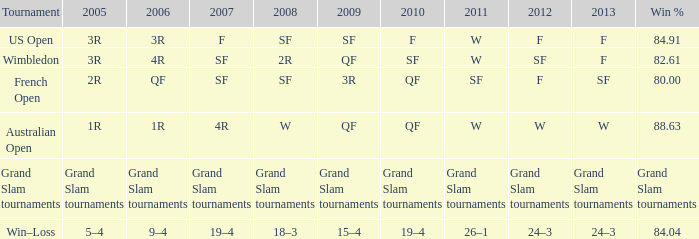In which tournament was there a 19-4 record in 2007? Win–Loss. 